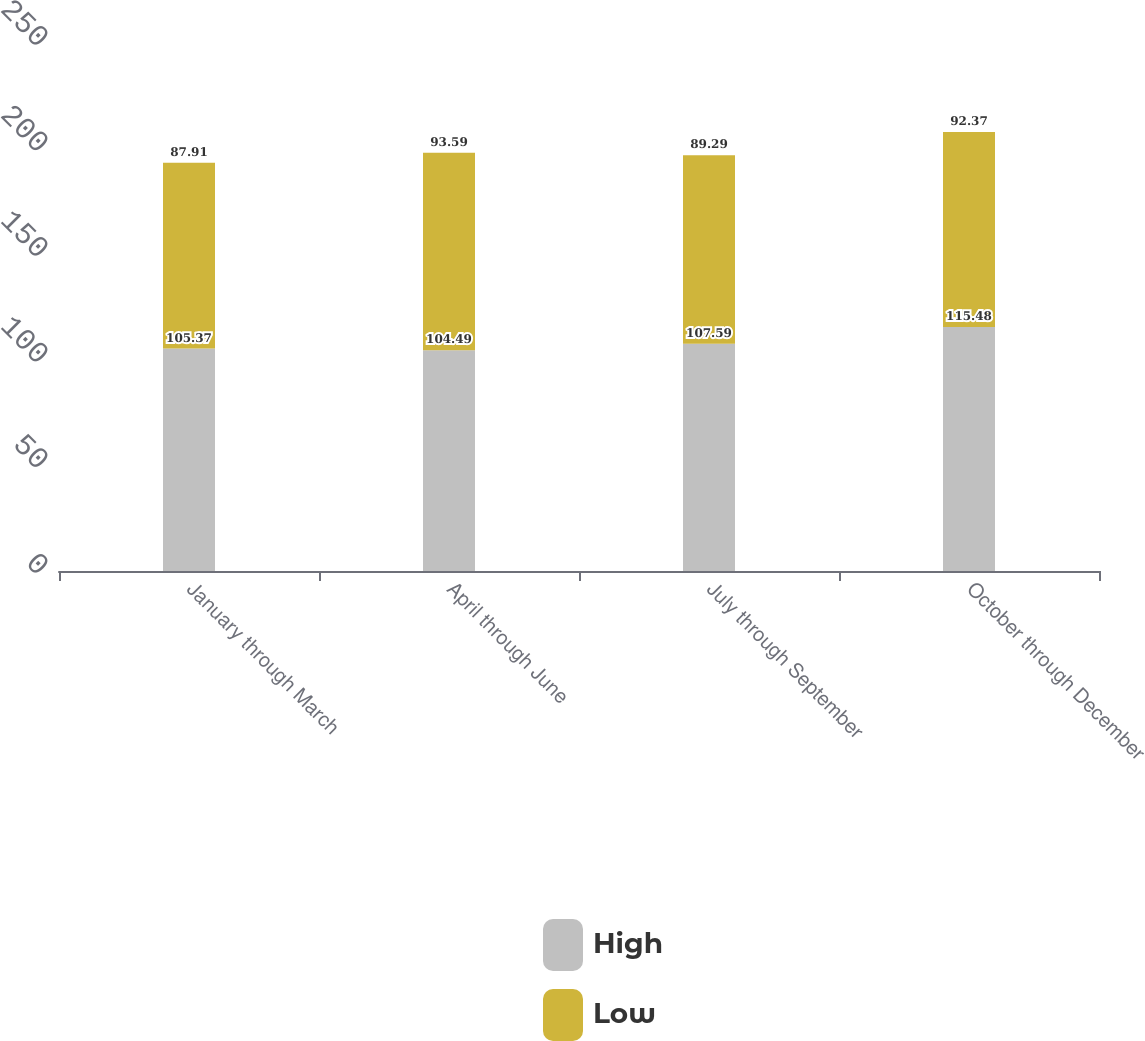Convert chart. <chart><loc_0><loc_0><loc_500><loc_500><stacked_bar_chart><ecel><fcel>January through March<fcel>April through June<fcel>July through September<fcel>October through December<nl><fcel>High<fcel>105.37<fcel>104.49<fcel>107.59<fcel>115.48<nl><fcel>Low<fcel>87.91<fcel>93.59<fcel>89.29<fcel>92.37<nl></chart> 